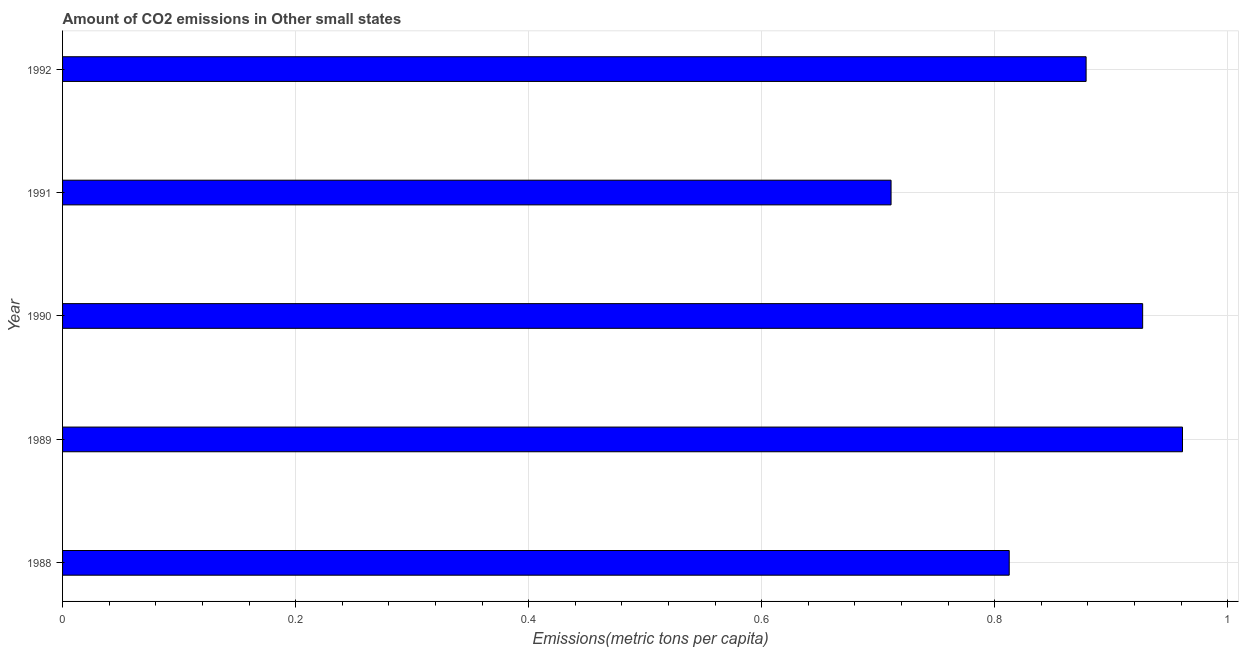What is the title of the graph?
Give a very brief answer. Amount of CO2 emissions in Other small states. What is the label or title of the X-axis?
Give a very brief answer. Emissions(metric tons per capita). What is the amount of co2 emissions in 1991?
Offer a terse response. 0.71. Across all years, what is the maximum amount of co2 emissions?
Give a very brief answer. 0.96. Across all years, what is the minimum amount of co2 emissions?
Provide a short and direct response. 0.71. What is the sum of the amount of co2 emissions?
Ensure brevity in your answer.  4.29. What is the difference between the amount of co2 emissions in 1989 and 1992?
Give a very brief answer. 0.08. What is the average amount of co2 emissions per year?
Your response must be concise. 0.86. What is the median amount of co2 emissions?
Offer a very short reply. 0.88. In how many years, is the amount of co2 emissions greater than 0.96 metric tons per capita?
Offer a very short reply. 1. Do a majority of the years between 1991 and 1988 (inclusive) have amount of co2 emissions greater than 0.24 metric tons per capita?
Offer a very short reply. Yes. What is the ratio of the amount of co2 emissions in 1990 to that in 1992?
Provide a short and direct response. 1.05. What is the difference between the highest and the second highest amount of co2 emissions?
Make the answer very short. 0.03. Is the sum of the amount of co2 emissions in 1988 and 1992 greater than the maximum amount of co2 emissions across all years?
Give a very brief answer. Yes. What is the difference between the highest and the lowest amount of co2 emissions?
Ensure brevity in your answer.  0.25. What is the difference between two consecutive major ticks on the X-axis?
Your response must be concise. 0.2. Are the values on the major ticks of X-axis written in scientific E-notation?
Ensure brevity in your answer.  No. What is the Emissions(metric tons per capita) of 1988?
Make the answer very short. 0.81. What is the Emissions(metric tons per capita) of 1989?
Your answer should be very brief. 0.96. What is the Emissions(metric tons per capita) in 1990?
Provide a short and direct response. 0.93. What is the Emissions(metric tons per capita) in 1991?
Provide a short and direct response. 0.71. What is the Emissions(metric tons per capita) of 1992?
Keep it short and to the point. 0.88. What is the difference between the Emissions(metric tons per capita) in 1988 and 1989?
Give a very brief answer. -0.15. What is the difference between the Emissions(metric tons per capita) in 1988 and 1990?
Offer a terse response. -0.11. What is the difference between the Emissions(metric tons per capita) in 1988 and 1991?
Make the answer very short. 0.1. What is the difference between the Emissions(metric tons per capita) in 1988 and 1992?
Your answer should be compact. -0.07. What is the difference between the Emissions(metric tons per capita) in 1989 and 1990?
Your response must be concise. 0.03. What is the difference between the Emissions(metric tons per capita) in 1989 and 1991?
Your answer should be very brief. 0.25. What is the difference between the Emissions(metric tons per capita) in 1989 and 1992?
Give a very brief answer. 0.08. What is the difference between the Emissions(metric tons per capita) in 1990 and 1991?
Make the answer very short. 0.22. What is the difference between the Emissions(metric tons per capita) in 1990 and 1992?
Your answer should be very brief. 0.05. What is the difference between the Emissions(metric tons per capita) in 1991 and 1992?
Make the answer very short. -0.17. What is the ratio of the Emissions(metric tons per capita) in 1988 to that in 1989?
Give a very brief answer. 0.84. What is the ratio of the Emissions(metric tons per capita) in 1988 to that in 1990?
Give a very brief answer. 0.88. What is the ratio of the Emissions(metric tons per capita) in 1988 to that in 1991?
Offer a very short reply. 1.14. What is the ratio of the Emissions(metric tons per capita) in 1988 to that in 1992?
Keep it short and to the point. 0.93. What is the ratio of the Emissions(metric tons per capita) in 1989 to that in 1991?
Your answer should be compact. 1.35. What is the ratio of the Emissions(metric tons per capita) in 1989 to that in 1992?
Your response must be concise. 1.09. What is the ratio of the Emissions(metric tons per capita) in 1990 to that in 1991?
Provide a short and direct response. 1.3. What is the ratio of the Emissions(metric tons per capita) in 1990 to that in 1992?
Offer a very short reply. 1.05. What is the ratio of the Emissions(metric tons per capita) in 1991 to that in 1992?
Make the answer very short. 0.81. 